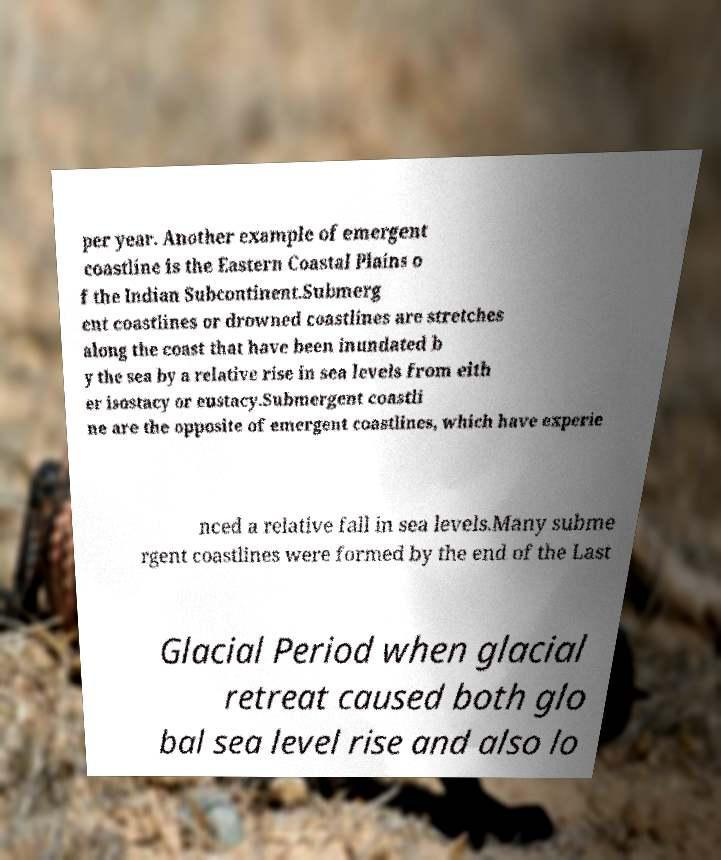Could you assist in decoding the text presented in this image and type it out clearly? per year. Another example of emergent coastline is the Eastern Coastal Plains o f the Indian Subcontinent.Submerg ent coastlines or drowned coastlines are stretches along the coast that have been inundated b y the sea by a relative rise in sea levels from eith er isostacy or eustacy.Submergent coastli ne are the opposite of emergent coastlines, which have experie nced a relative fall in sea levels.Many subme rgent coastlines were formed by the end of the Last Glacial Period when glacial retreat caused both glo bal sea level rise and also lo 